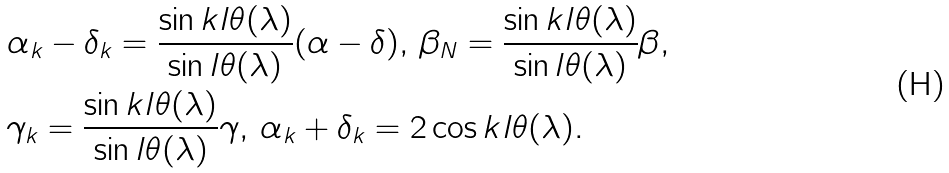Convert formula to latex. <formula><loc_0><loc_0><loc_500><loc_500>& \alpha _ { k } - \delta _ { k } = \frac { \sin k l \theta ( \lambda ) } { \sin l \theta ( \lambda ) } ( \alpha - \delta ) , \, \beta _ { N } = \frac { \sin k l \theta ( \lambda ) } { \sin l \theta ( \lambda ) } \beta , \\ & \gamma _ { k } = \frac { \sin k l \theta ( \lambda ) } { \sin l \theta ( \lambda ) } \gamma , \, \alpha _ { k } + \delta _ { k } = 2 \cos k l \theta ( \lambda ) .</formula> 